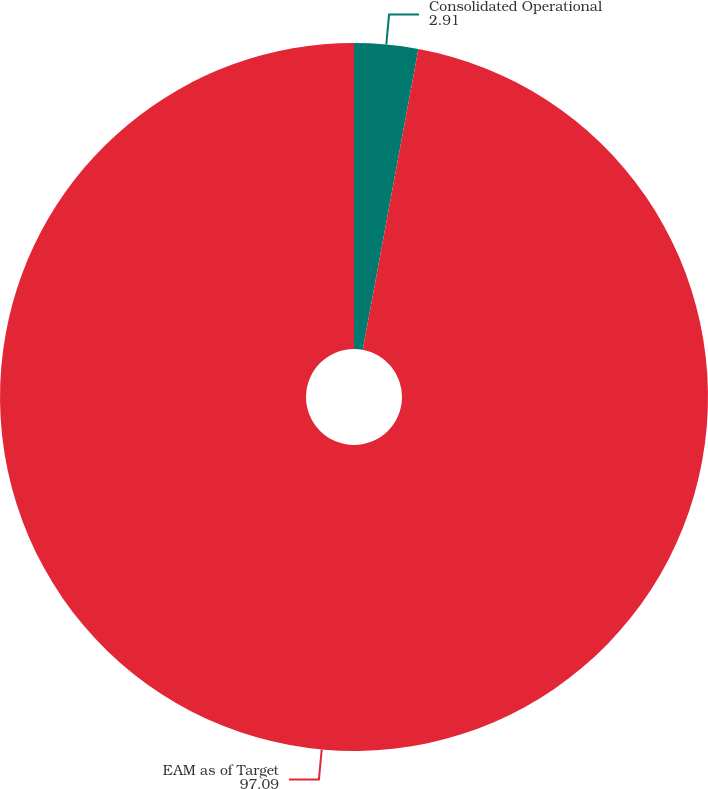<chart> <loc_0><loc_0><loc_500><loc_500><pie_chart><fcel>Consolidated Operational<fcel>EAM as of Target<nl><fcel>2.91%<fcel>97.09%<nl></chart> 